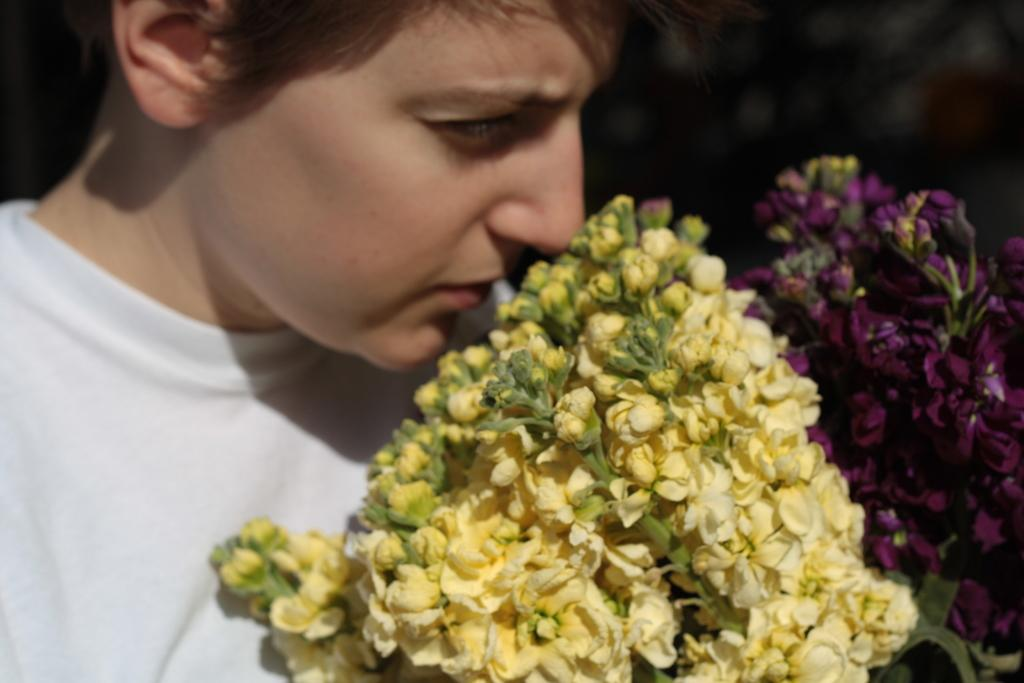What is the main subject of the image? There is a person in the image. What is the person doing in the image? The person is standing. What other objects or elements can be seen in the image? There are flowers in the image. What is the caption written on the person's shirt in the image? There is no caption written on the person's shirt in the image, as we cannot see any text on their clothing. Can you see a cat in the image? No, there is no cat present in the image. 